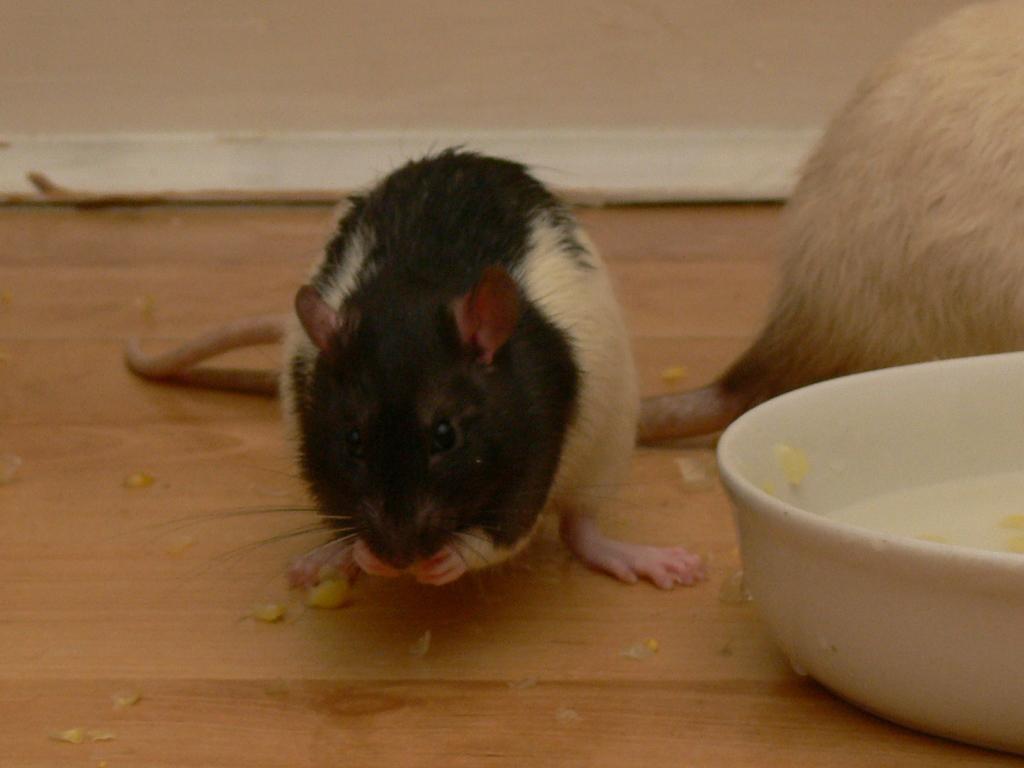Describe this image in one or two sentences. On this wooden surface we can see rats and bowl. 